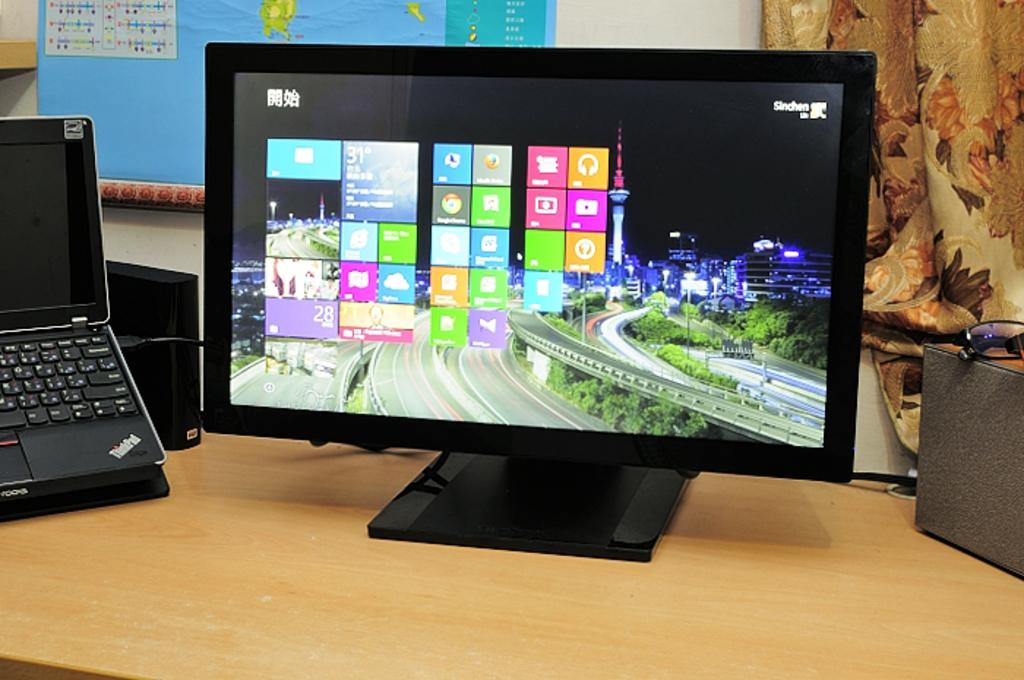<image>
Offer a succinct explanation of the picture presented. An illuminated computer screen showing the current temperature at 31 degrees. 